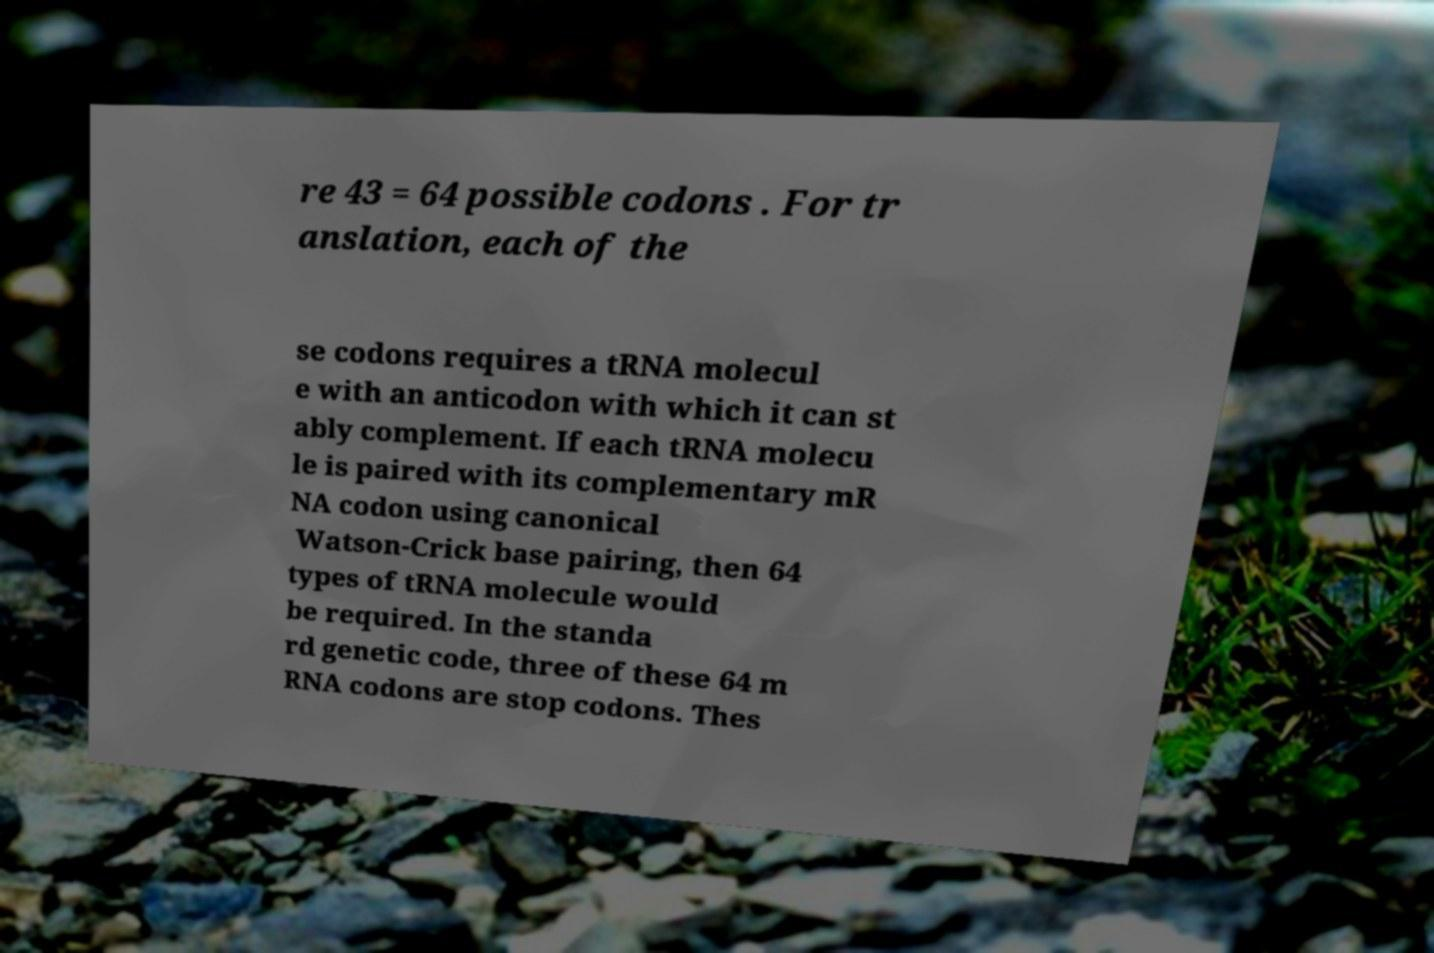Please identify and transcribe the text found in this image. re 43 = 64 possible codons . For tr anslation, each of the se codons requires a tRNA molecul e with an anticodon with which it can st ably complement. If each tRNA molecu le is paired with its complementary mR NA codon using canonical Watson-Crick base pairing, then 64 types of tRNA molecule would be required. In the standa rd genetic code, three of these 64 m RNA codons are stop codons. Thes 